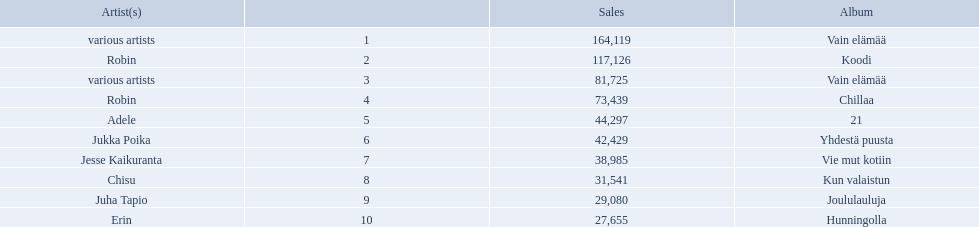Who is the artist for 21 album? Adele. Who is the artist for kun valaistun? Chisu. Which album had the same artist as chillaa? Koodi. What sales does adele have? 44,297. What sales does chisu have? 31,541. Which of these numbers are higher? 44,297. Who has this number of sales? Adele. 